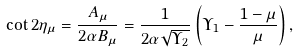Convert formula to latex. <formula><loc_0><loc_0><loc_500><loc_500>\cot 2 \eta _ { \mu } = \frac { A _ { \mu } } { 2 \alpha B _ { \mu } } = \frac { 1 } { 2 \alpha \sqrt { \Upsilon _ { 2 } } } \left ( \Upsilon _ { 1 } - \frac { 1 - \mu } { \mu } \right ) ,</formula> 